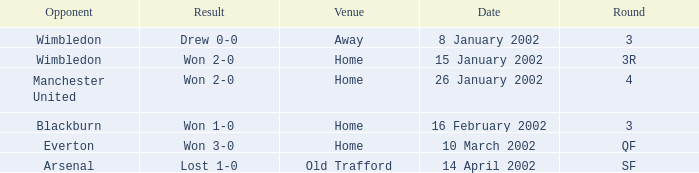Could you help me parse every detail presented in this table? {'header': ['Opponent', 'Result', 'Venue', 'Date', 'Round'], 'rows': [['Wimbledon', 'Drew 0-0', 'Away', '8 January 2002', '3'], ['Wimbledon', 'Won 2-0', 'Home', '15 January 2002', '3R'], ['Manchester United', 'Won 2-0', 'Home', '26 January 2002', '4'], ['Blackburn', 'Won 1-0', 'Home', '16 February 2002', '3'], ['Everton', 'Won 3-0', 'Home', '10 March 2002', 'QF'], ['Arsenal', 'Lost 1-0', 'Old Trafford', '14 April 2002', 'SF']]} What is the Date with a Opponent with wimbledon, and a Result of won 2-0? 15 January 2002. 